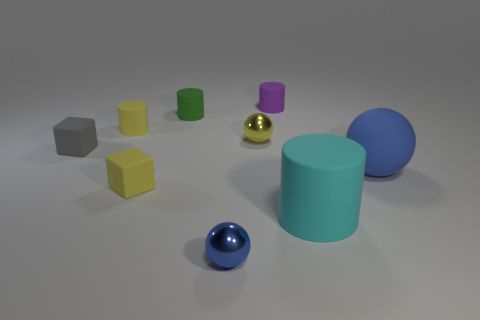Subtract all brown cylinders. Subtract all green spheres. How many cylinders are left? 4 Add 1 small yellow matte things. How many objects exist? 10 Subtract all cubes. How many objects are left? 7 Add 3 cyan objects. How many cyan objects are left? 4 Add 1 purple rubber balls. How many purple rubber balls exist? 1 Subtract 0 green spheres. How many objects are left? 9 Subtract all yellow cylinders. Subtract all rubber cylinders. How many objects are left? 4 